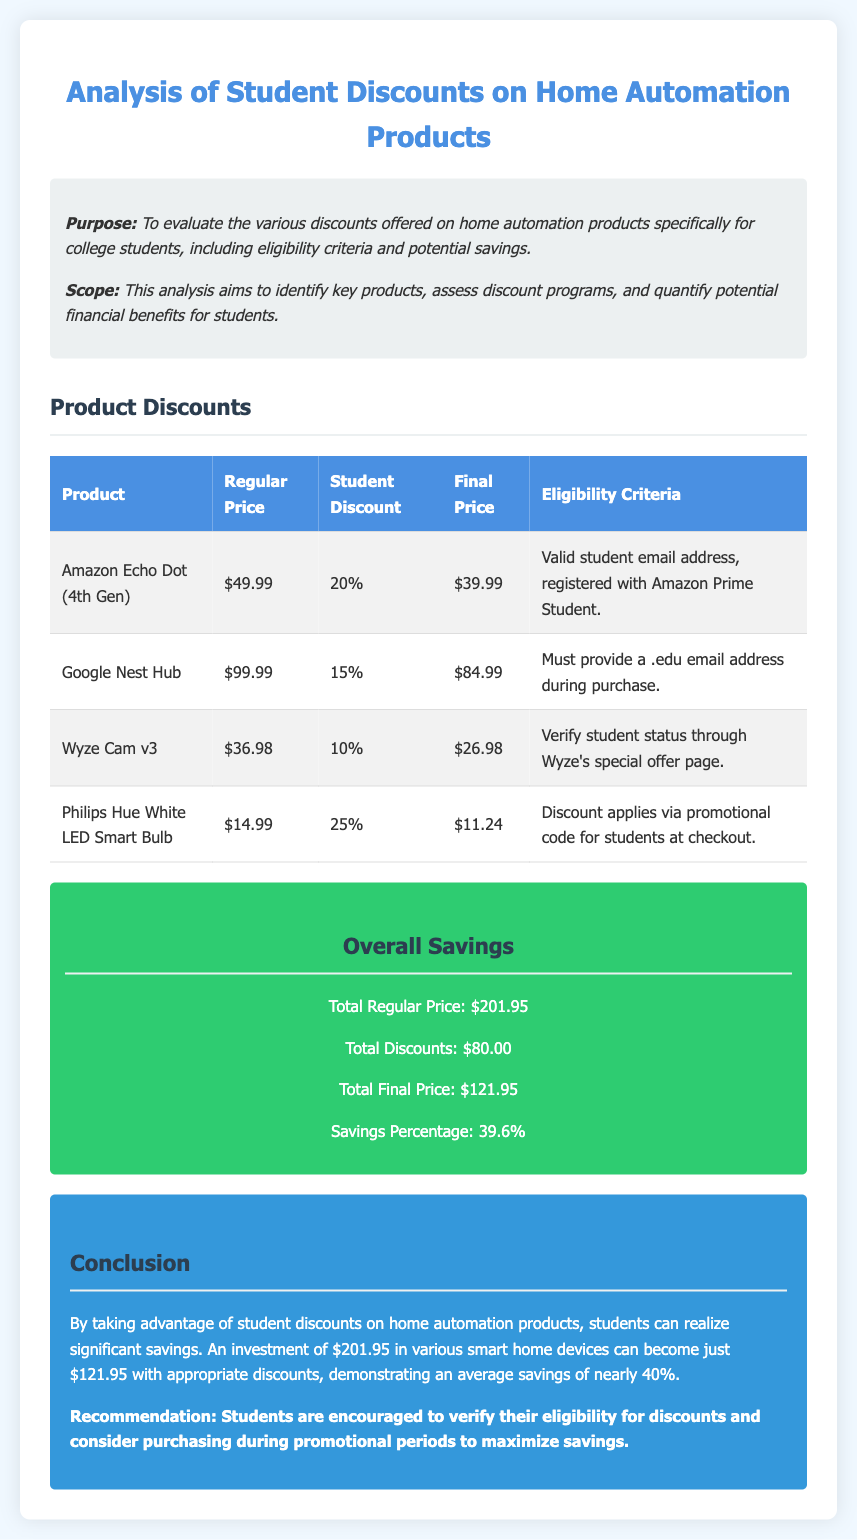what is the student discount for the Amazon Echo Dot (4th Gen)? The Amazon Echo Dot (4th Gen) has a student discount of 20%.
Answer: 20% what is the final price of the Google Nest Hub after the student discount? The final price of the Google Nest Hub after the student discount is $84.99.
Answer: $84.99 which product offers the highest student discount percentage? The Philips Hue White LED Smart Bulb offers the highest student discount percentage of 25%.
Answer: 25% how much total savings can students expect when purchasing all listed products? Total savings when purchasing all listed products is $80.00.
Answer: $80.00 what is the eligibility requirement for the Wyze Cam v3 discount? The eligibility requirement for the Wyze Cam v3 discount is to verify student status through Wyze's special offer page.
Answer: Verify student status what is the sum of the regular prices of all products listed? The sum of the regular prices of all products listed is $201.95.
Answer: $201.95 what is the total percentage of savings students can achieve? The total percentage of savings students can achieve is 39.6%.
Answer: 39.6% what is the recommended action for students to maximize their savings? The recommended action for students to maximize their savings is to verify their eligibility for discounts and consider purchasing during promotional periods.
Answer: Verify eligibility and purchase during promotions 